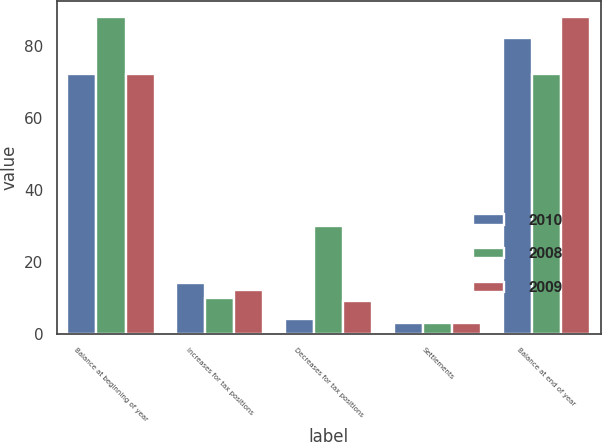Convert chart to OTSL. <chart><loc_0><loc_0><loc_500><loc_500><stacked_bar_chart><ecel><fcel>Balance at beginning of year<fcel>Increases for tax positions<fcel>Decreases for tax positions<fcel>Settlements<fcel>Balance at end of year<nl><fcel>2010<fcel>72<fcel>14<fcel>4<fcel>3<fcel>82<nl><fcel>2008<fcel>88<fcel>10<fcel>30<fcel>3<fcel>72<nl><fcel>2009<fcel>72<fcel>12<fcel>9<fcel>3<fcel>88<nl></chart> 